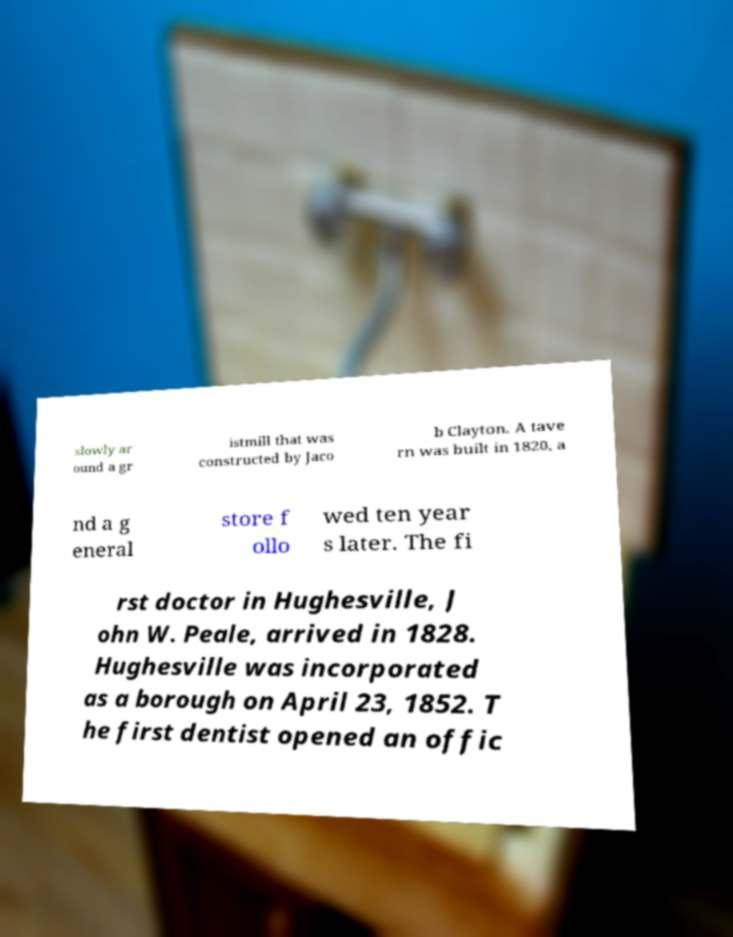For documentation purposes, I need the text within this image transcribed. Could you provide that? slowly ar ound a gr istmill that was constructed by Jaco b Clayton. A tave rn was built in 1820, a nd a g eneral store f ollo wed ten year s later. The fi rst doctor in Hughesville, J ohn W. Peale, arrived in 1828. Hughesville was incorporated as a borough on April 23, 1852. T he first dentist opened an offic 